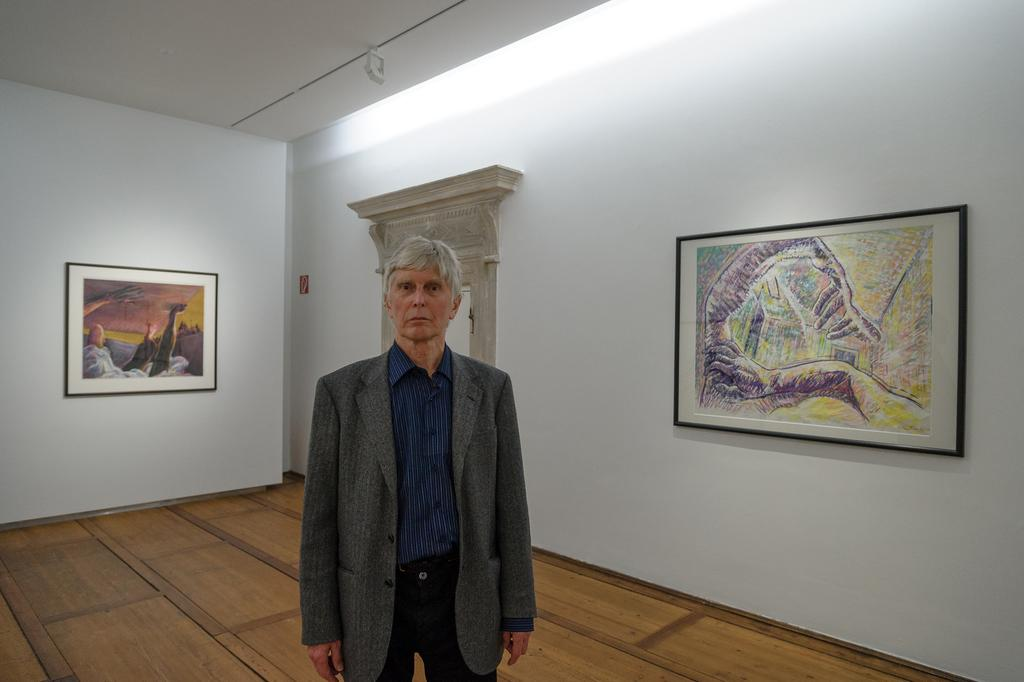What is the main subject of the image? There is a man standing in the image. What can be seen in the background of the image? There is a wall with frames in the background. Can you describe any specific design on the wall? Yes, there is an arch design on the wall. What type of dress is the man wearing in the image? The man is not wearing a dress in the image; he is wearing regular clothing. How many cars can be seen parked near the man in the image? There are no cars visible in the image; it only features the man and the wall with frames. 